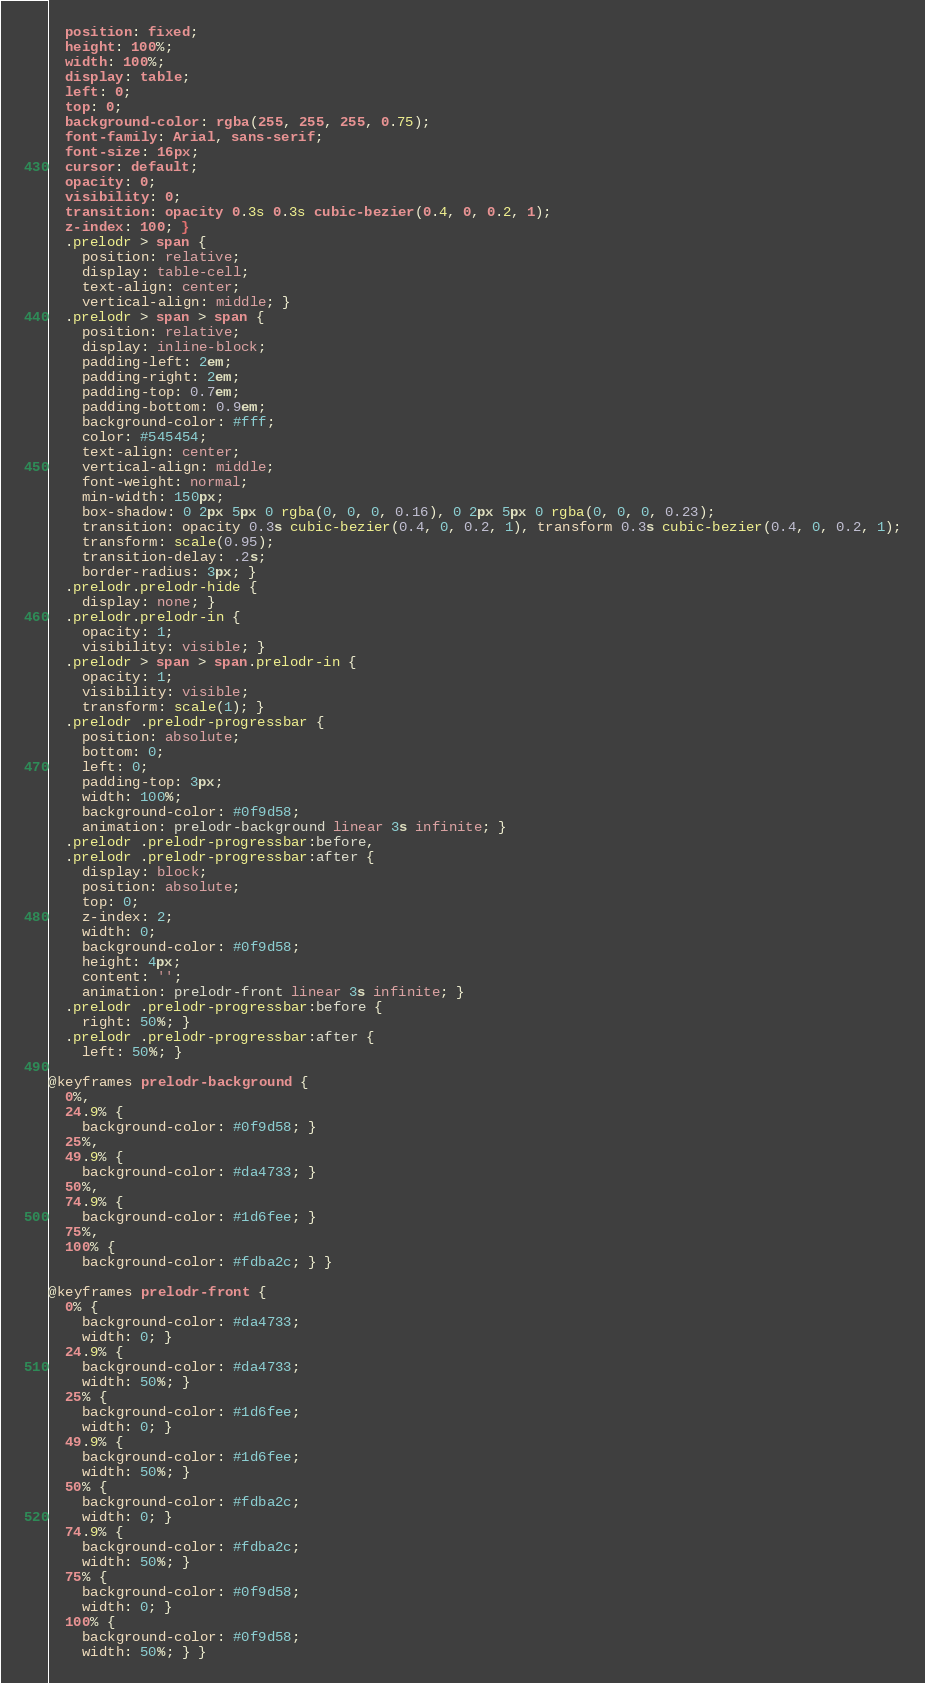Convert code to text. <code><loc_0><loc_0><loc_500><loc_500><_CSS_>  position: fixed;
  height: 100%;
  width: 100%;
  display: table;
  left: 0;
  top: 0;
  background-color: rgba(255, 255, 255, 0.75);
  font-family: Arial, sans-serif;
  font-size: 16px;
  cursor: default;
  opacity: 0;
  visibility: 0;
  transition: opacity 0.3s 0.3s cubic-bezier(0.4, 0, 0.2, 1);
  z-index: 100; }
  .prelodr > span {
    position: relative;
    display: table-cell;
    text-align: center;
    vertical-align: middle; }
  .prelodr > span > span {
    position: relative;
    display: inline-block;
    padding-left: 2em;
    padding-right: 2em;
    padding-top: 0.7em;
    padding-bottom: 0.9em;
    background-color: #fff;
    color: #545454;
    text-align: center;
    vertical-align: middle;
    font-weight: normal;
    min-width: 150px;
    box-shadow: 0 2px 5px 0 rgba(0, 0, 0, 0.16), 0 2px 5px 0 rgba(0, 0, 0, 0.23);
    transition: opacity 0.3s cubic-bezier(0.4, 0, 0.2, 1), transform 0.3s cubic-bezier(0.4, 0, 0.2, 1);
    transform: scale(0.95);
    transition-delay: .2s;
    border-radius: 3px; }
  .prelodr.prelodr-hide {
    display: none; }
  .prelodr.prelodr-in {
    opacity: 1;
    visibility: visible; }
  .prelodr > span > span.prelodr-in {
    opacity: 1;
    visibility: visible;
    transform: scale(1); }
  .prelodr .prelodr-progressbar {
    position: absolute;
    bottom: 0;
    left: 0;
    padding-top: 3px;
    width: 100%;
    background-color: #0f9d58;
    animation: prelodr-background linear 3s infinite; }
  .prelodr .prelodr-progressbar:before,
  .prelodr .prelodr-progressbar:after {
    display: block;
    position: absolute;
    top: 0;
    z-index: 2;
    width: 0;
    background-color: #0f9d58;
    height: 4px;
    content: '';
    animation: prelodr-front linear 3s infinite; }
  .prelodr .prelodr-progressbar:before {
    right: 50%; }
  .prelodr .prelodr-progressbar:after {
    left: 50%; }

@keyframes prelodr-background {
  0%,
  24.9% {
    background-color: #0f9d58; }
  25%,
  49.9% {
    background-color: #da4733; }
  50%,
  74.9% {
    background-color: #1d6fee; }
  75%,
  100% {
    background-color: #fdba2c; } }

@keyframes prelodr-front {
  0% {
    background-color: #da4733;
    width: 0; }
  24.9% {
    background-color: #da4733;
    width: 50%; }
  25% {
    background-color: #1d6fee;
    width: 0; }
  49.9% {
    background-color: #1d6fee;
    width: 50%; }
  50% {
    background-color: #fdba2c;
    width: 0; }
  74.9% {
    background-color: #fdba2c;
    width: 50%; }
  75% {
    background-color: #0f9d58;
    width: 0; }
  100% {
    background-color: #0f9d58;
    width: 50%; } }
</code> 